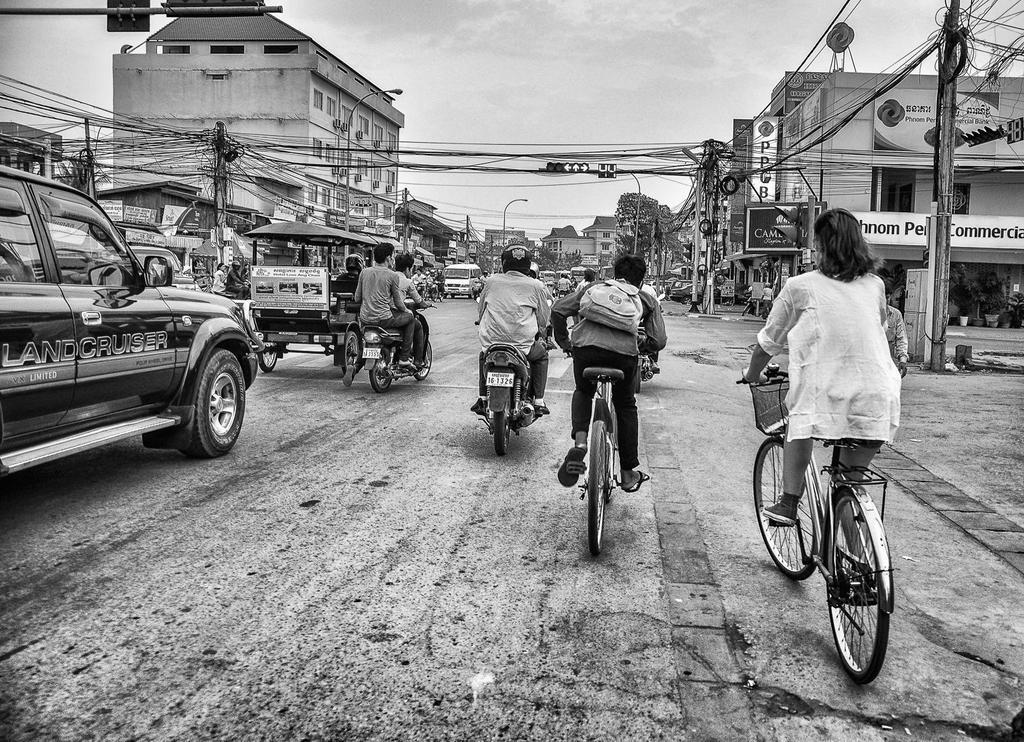How would you summarize this image in a sentence or two? In this image we can see few persons are riding a vehicle on the road. At the background we can see a building and a traffic signal and we can see a pole and a sky. 